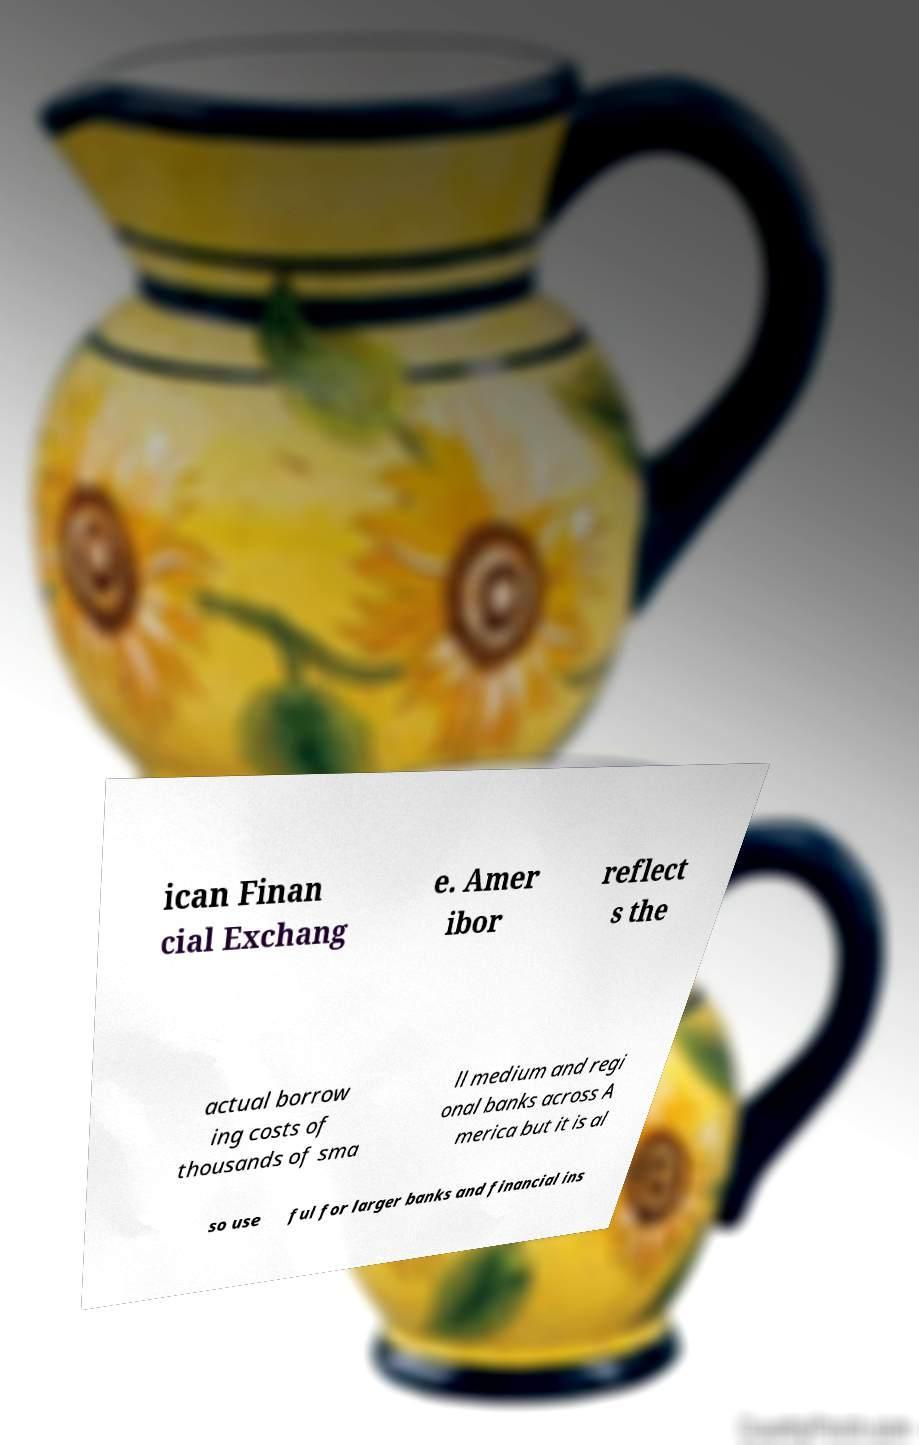Could you assist in decoding the text presented in this image and type it out clearly? ican Finan cial Exchang e. Amer ibor reflect s the actual borrow ing costs of thousands of sma ll medium and regi onal banks across A merica but it is al so use ful for larger banks and financial ins 